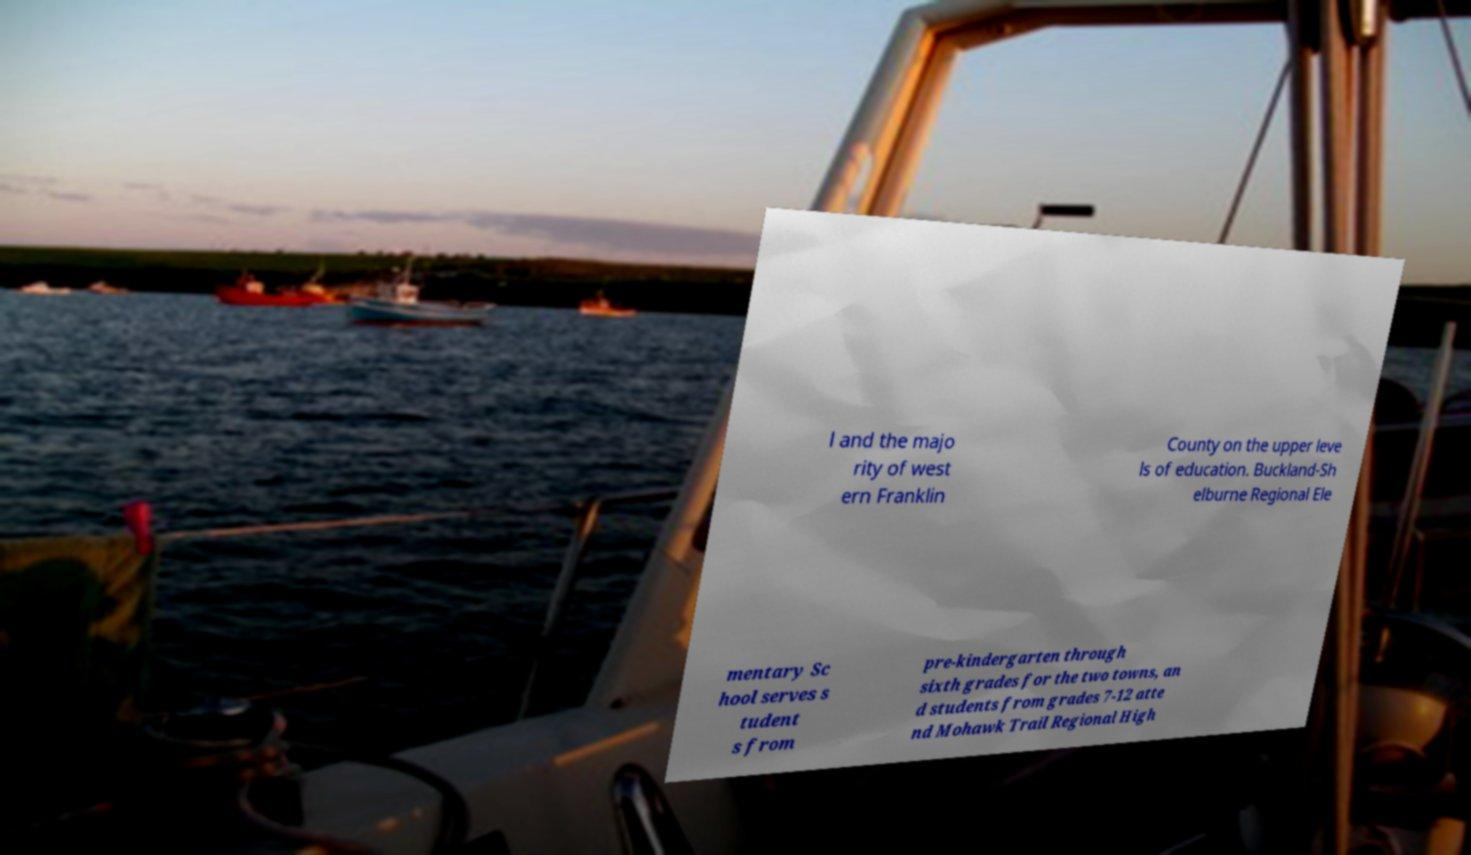Please identify and transcribe the text found in this image. l and the majo rity of west ern Franklin County on the upper leve ls of education. Buckland-Sh elburne Regional Ele mentary Sc hool serves s tudent s from pre-kindergarten through sixth grades for the two towns, an d students from grades 7-12 atte nd Mohawk Trail Regional High 